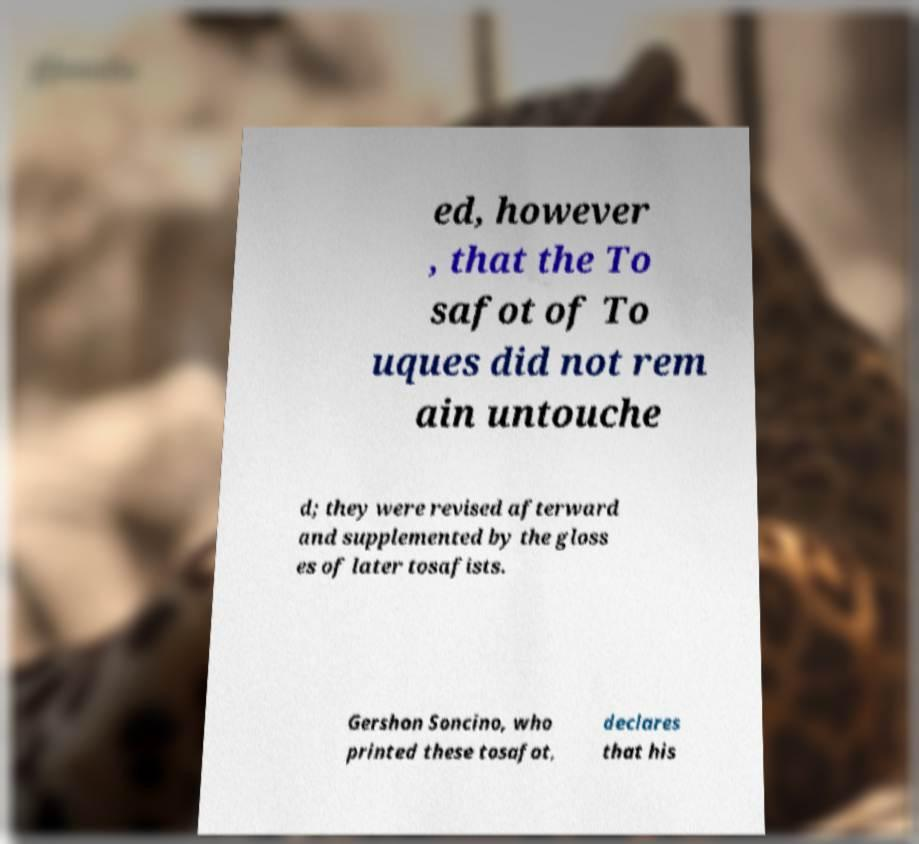Could you assist in decoding the text presented in this image and type it out clearly? ed, however , that the To safot of To uques did not rem ain untouche d; they were revised afterward and supplemented by the gloss es of later tosafists. Gershon Soncino, who printed these tosafot, declares that his 